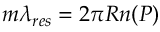Convert formula to latex. <formula><loc_0><loc_0><loc_500><loc_500>m \lambda _ { r e s } = 2 \pi R n ( P )</formula> 